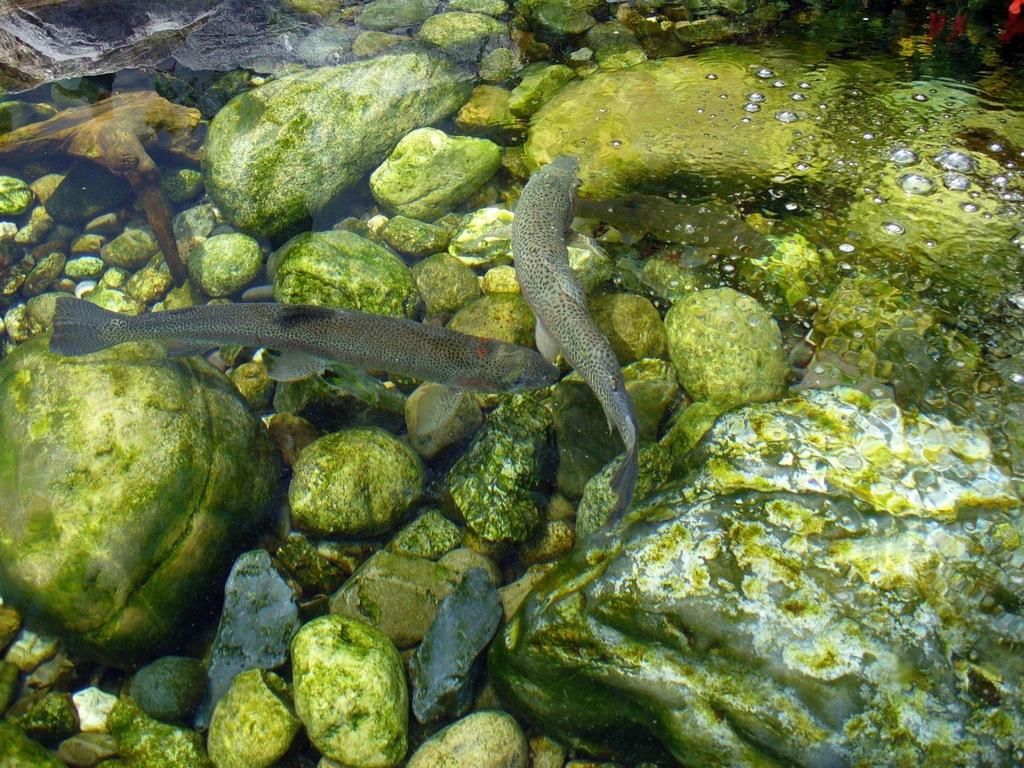What is happening in the water in the image? There are fishes swimming in the water. What else can be seen in the image besides the fishes? There are rocks in the image, and there is moss on the rocks. Can you describe the water in the image? There are water bubbles on the right side of the image. How many planes can be seen flying over the water in the image? There are no planes visible in the image; it features fishes swimming in the water with rocks and moss. Are there any balls bouncing on the rocks in the image? There are no balls present in the image; it features fishes swimming in the water with rocks and moss. 